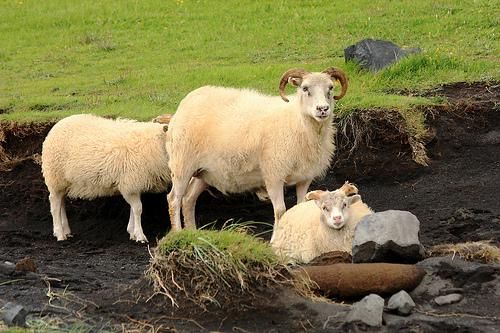State the color and appearance of the rams' various features, such as horns, fur, and eyes. The rams have brown horns, white fluffy fur, small orange noses with a pink touch, and small black eyes. Describe the image by mentioning the position and type of the rams and their environment. Three rams, including a baby ram, are positioned near a creek surrounded by an empty river bed, a field, and green bushes. Describe the setting of the image, including the environment and any natural elements. The rams are in an area with a creek, an empty river bed, a field, and topped green bushes in the surroundings. What are the animals in the picture doing, and what are their most prominent features? Rams are standing and lying in a creek with one baby ram, each having distinct horns, white fur, and black eyes. Mention the distinct features of the rams in the image and their visible body parts. The rams showcase white fluffy fur, long legs, horns in different shades of brown, and small black eyes. Depict the image, focusing on the baby ram and its notable attributes. The baby ram lies down with small horns, a white face, white furry legs, and an orange nose surrounded by other rams. Discuss the different types of horns present on the rams in the image. The rams have brown horns in various shades, sizes, andshapes - ranging from large and curved to small and straight. Narrate the image by describing the interaction between the baby ram and the other rams. A baby ram is lying peacefully on the ground as the adult rams stand watchfully around it, forming a protective huddle. Give a brief summary of the image, emphasizing the presence and location of the rams. In the picture, three rams are gathered near a creek, with one adult ram standing and a baby ram lying down. Provide a brief description of the primary scene in the image. Three rams are standing together near a creek, with one baby ram lying down and a brown rock beside them. 